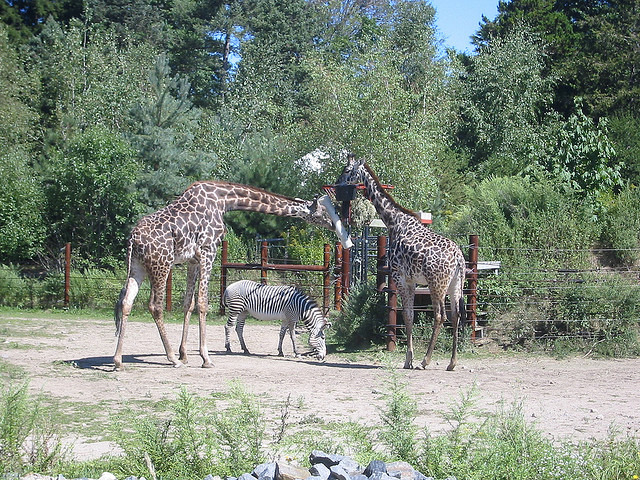Can you tell me about the habitat in which these giraffes and zebra live? Certainly! The image showcases giraffes and a zebra in a human-made habitat, designed to resemble an open savanna environment. This type of habitat typically includes wide-open spaces, plenty of sunlight, and sparse trees. It is specially tailored to meet the needs of these animals, providing them space to roam and the appropriate foliage for their diet, which mirrors their natural African grassland homes. 